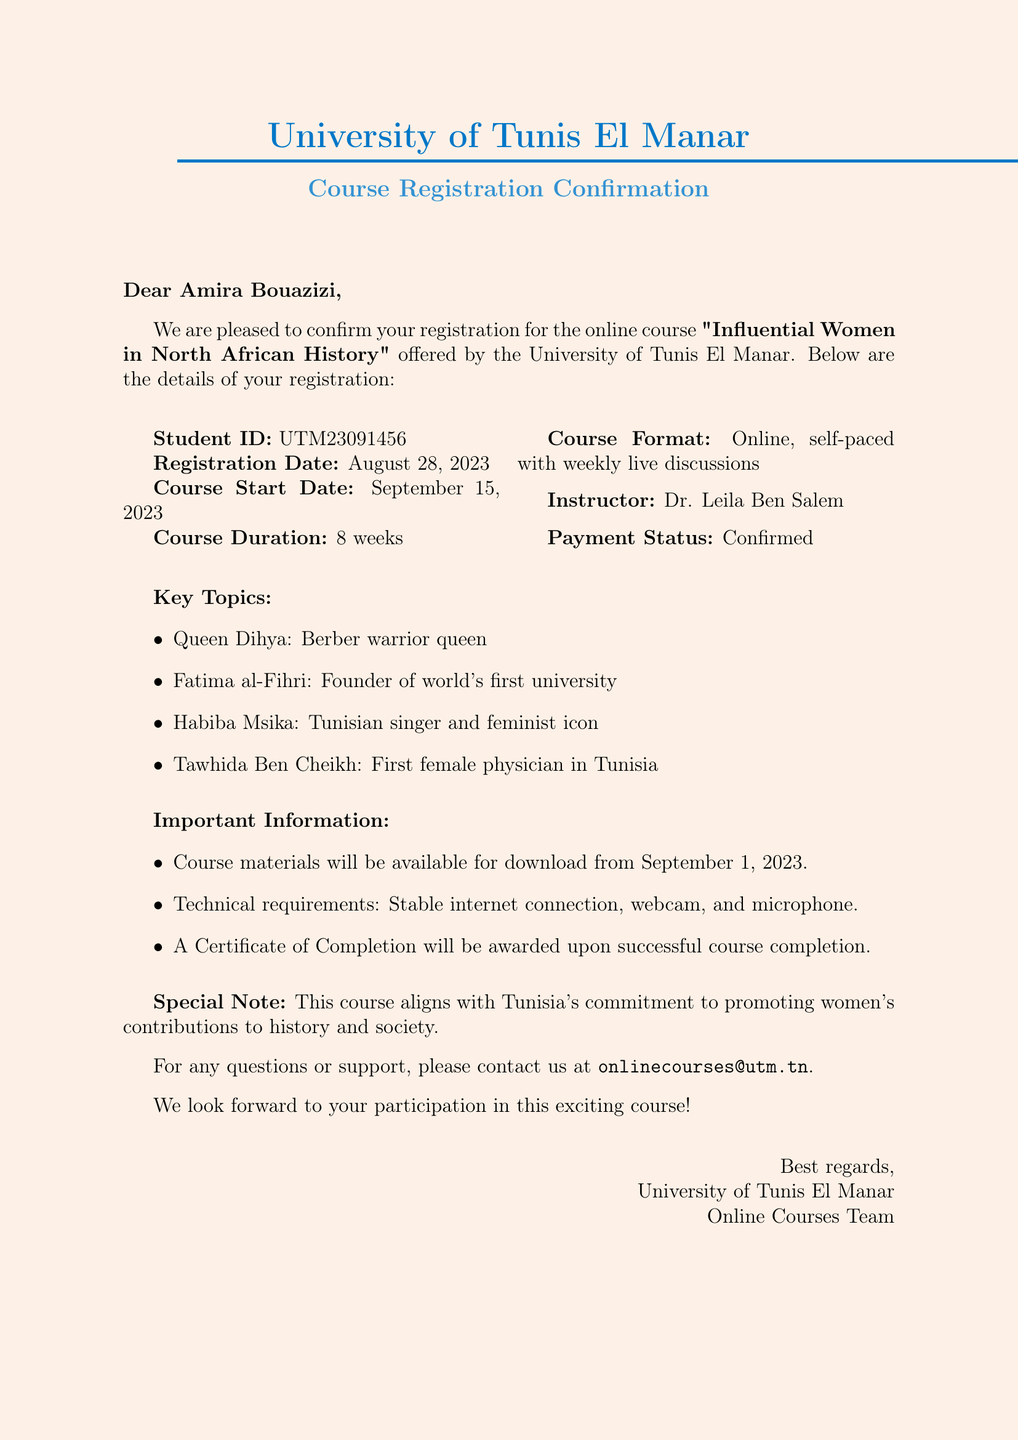What is the name of the university? The university's name is mentioned at the beginning of the document.
Answer: University of Tunis El Manar Who is the instructor for the course? The instructor's name is listed in the course details.
Answer: Dr. Leila Ben Salem When does the course start? The start date of the course is explicitly stated in the document.
Answer: September 15, 2023 What is the duration of the course? The duration of the course is specified in the course details section.
Answer: 8 weeks What is the payment status for the course? The payment status is clearly indicated in the registration details.
Answer: Confirmed What key topic addresses a historical figure known as a warrior queen? The key topics include notable historical women, and one is specifically a warrior queen.
Answer: Queen Dihya What technical requirements are mentioned for the course? The document lists the necessary technical specifications for attending the course.
Answer: Stable internet connection, webcam, and microphone What will be awarded upon successful course completion? The document mentions a certificate that will be provided after completion.
Answer: Certificate of Completion What email address should be used for support? The support email is provided at the end of the document.
Answer: onlinecourses@utm.tn 